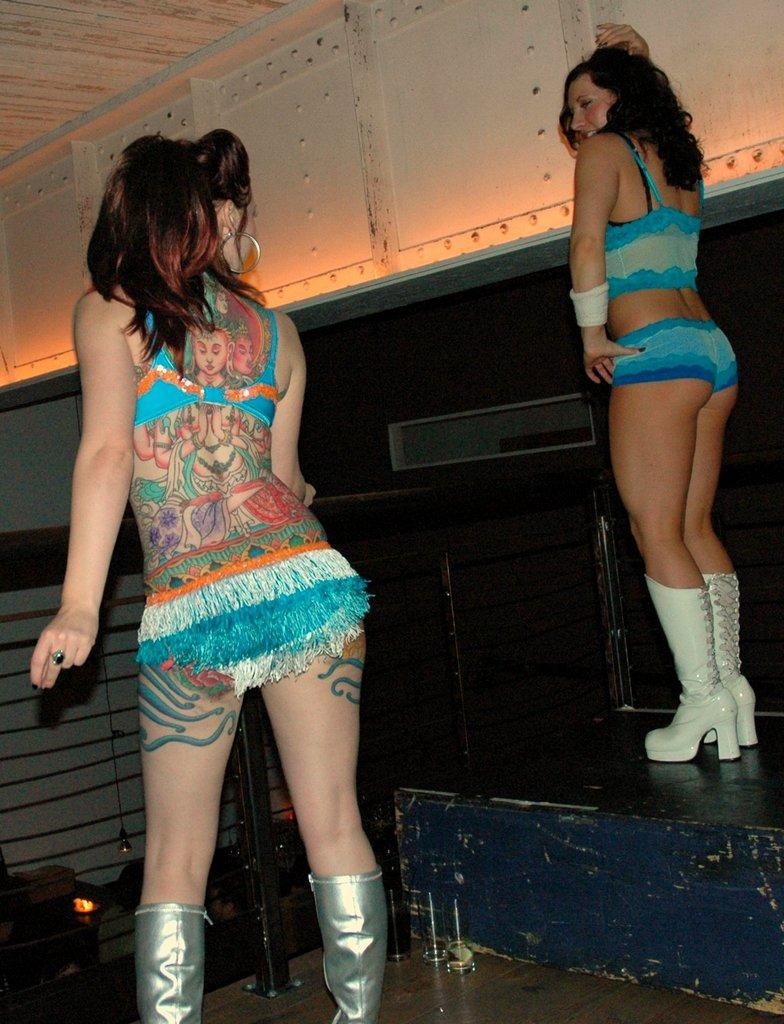How many women are in the image? There are two women in the image. Where is each woman positioned in relation to the other? One woman is standing on the left side, and the other woman is standing on the right side, on a step floor. What can be observed about the woman on the right side? The woman on the right side is wearing white shoes. What are the women doing in the image? Both women are dancing. What type of chicken can be seen in the alley behind the women? There is no chicken or alley present in the image; it features two women dancing. What is the purpose of the step floor in the image? The step floor is not mentioned to have a specific purpose in the image; it is simply a part of the setting where the woman on the right side is standing. 